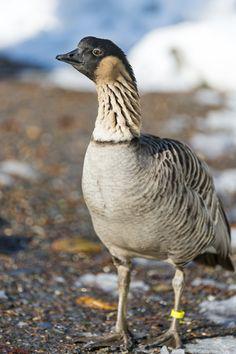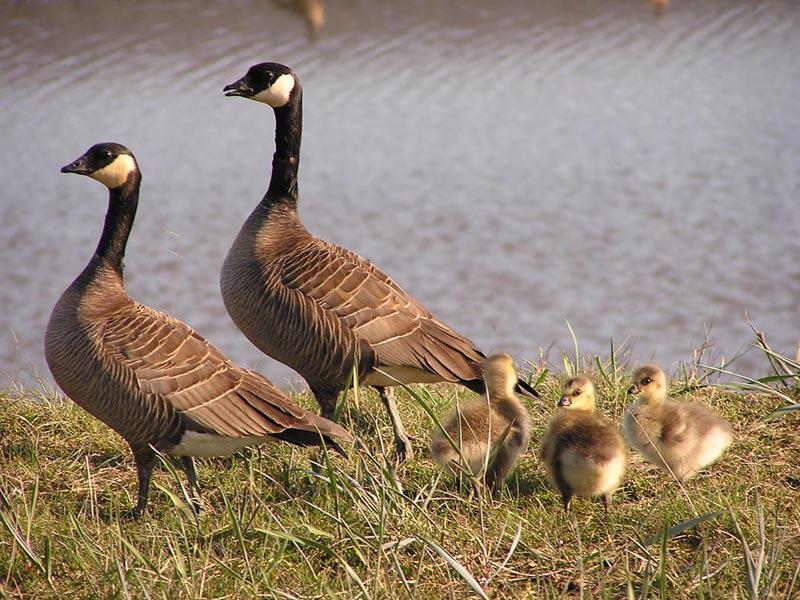The first image is the image on the left, the second image is the image on the right. For the images shown, is this caption "The right image shows ducks with multiple ducklings." true? Answer yes or no. Yes. 